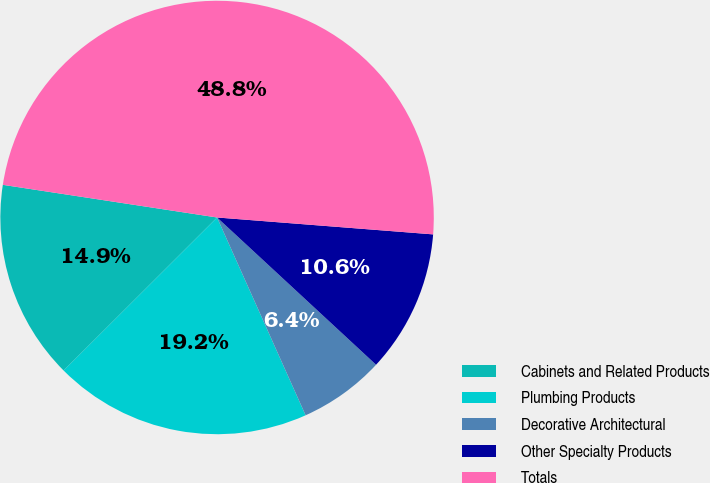Convert chart. <chart><loc_0><loc_0><loc_500><loc_500><pie_chart><fcel>Cabinets and Related Products<fcel>Plumbing Products<fcel>Decorative Architectural<fcel>Other Specialty Products<fcel>Totals<nl><fcel>14.89%<fcel>19.22%<fcel>6.41%<fcel>10.65%<fcel>48.84%<nl></chart> 